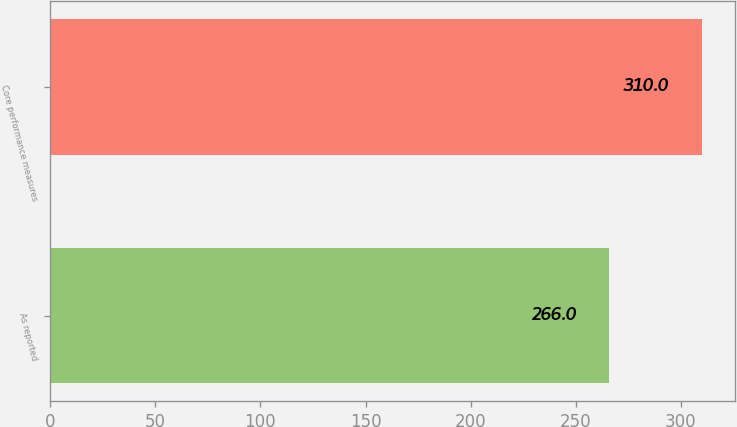Convert chart to OTSL. <chart><loc_0><loc_0><loc_500><loc_500><bar_chart><fcel>As reported<fcel>Core performance measures<nl><fcel>266<fcel>310<nl></chart> 